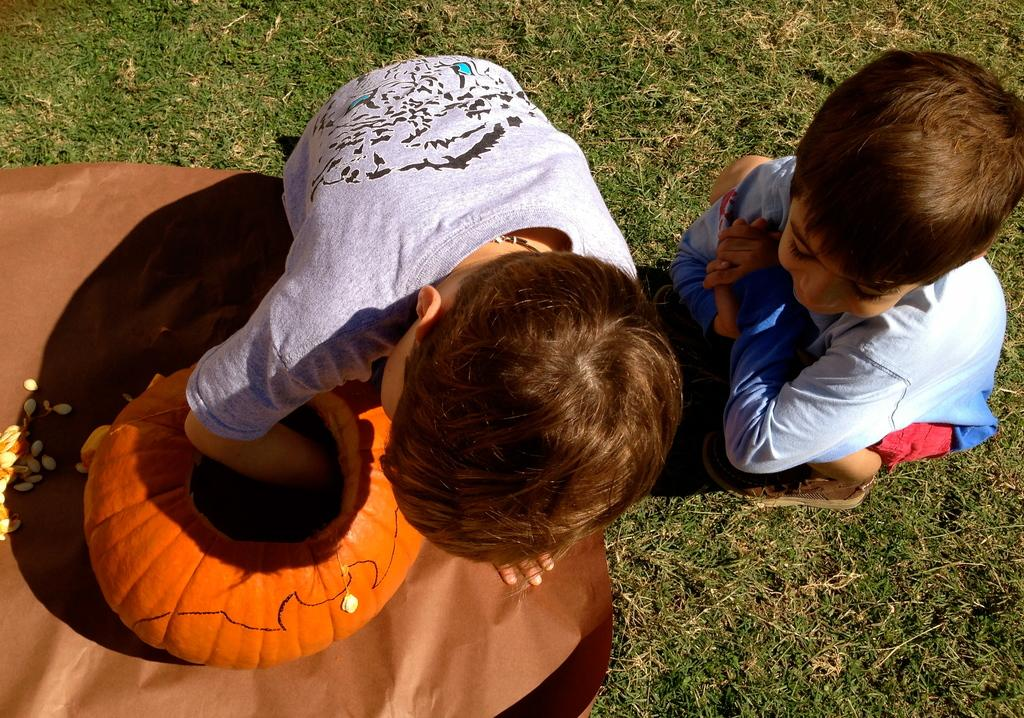How many people are in the image? There are a few people in the image. What is the ground covered with? The ground is covered with grass. What can be seen on the ground besides grass? There are objects visible on the ground. What is the pot used for in the image? The pot might be used for planting or holding seeds, as there are seeds in the image. Can you see a baby saying good-bye to a squirrel in the image? There is no baby or squirrel present in the image, so this scenario cannot be observed. 